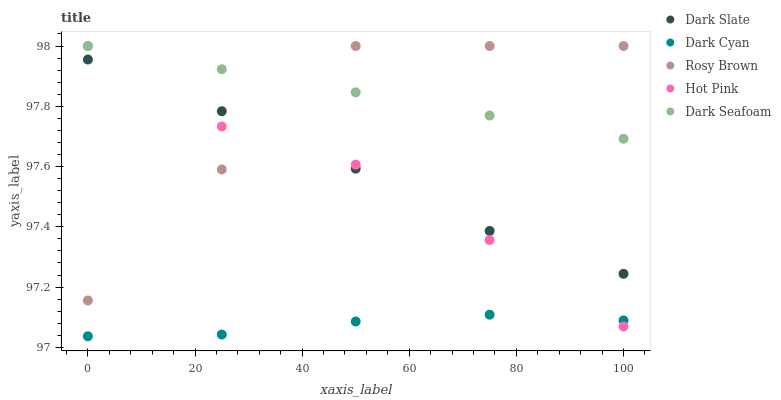Does Dark Cyan have the minimum area under the curve?
Answer yes or no. Yes. Does Dark Seafoam have the maximum area under the curve?
Answer yes or no. Yes. Does Dark Slate have the minimum area under the curve?
Answer yes or no. No. Does Dark Slate have the maximum area under the curve?
Answer yes or no. No. Is Dark Seafoam the smoothest?
Answer yes or no. Yes. Is Rosy Brown the roughest?
Answer yes or no. Yes. Is Dark Slate the smoothest?
Answer yes or no. No. Is Dark Slate the roughest?
Answer yes or no. No. Does Dark Cyan have the lowest value?
Answer yes or no. Yes. Does Dark Slate have the lowest value?
Answer yes or no. No. Does Hot Pink have the highest value?
Answer yes or no. Yes. Does Dark Slate have the highest value?
Answer yes or no. No. Is Dark Cyan less than Dark Seafoam?
Answer yes or no. Yes. Is Dark Seafoam greater than Dark Slate?
Answer yes or no. Yes. Does Hot Pink intersect Rosy Brown?
Answer yes or no. Yes. Is Hot Pink less than Rosy Brown?
Answer yes or no. No. Is Hot Pink greater than Rosy Brown?
Answer yes or no. No. Does Dark Cyan intersect Dark Seafoam?
Answer yes or no. No. 